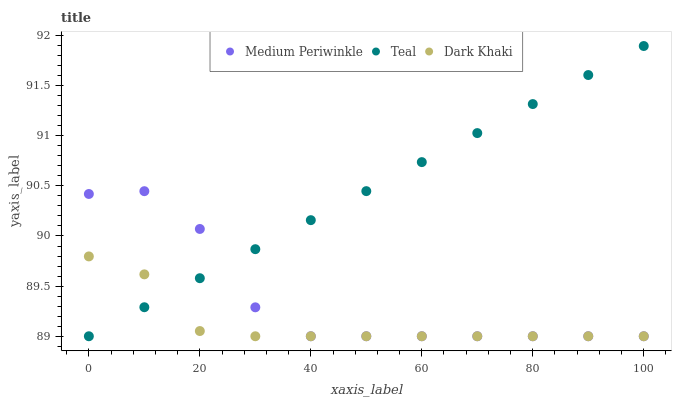Does Dark Khaki have the minimum area under the curve?
Answer yes or no. Yes. Does Teal have the maximum area under the curve?
Answer yes or no. Yes. Does Medium Periwinkle have the minimum area under the curve?
Answer yes or no. No. Does Medium Periwinkle have the maximum area under the curve?
Answer yes or no. No. Is Teal the smoothest?
Answer yes or no. Yes. Is Medium Periwinkle the roughest?
Answer yes or no. Yes. Is Medium Periwinkle the smoothest?
Answer yes or no. No. Is Teal the roughest?
Answer yes or no. No. Does Dark Khaki have the lowest value?
Answer yes or no. Yes. Does Teal have the highest value?
Answer yes or no. Yes. Does Medium Periwinkle have the highest value?
Answer yes or no. No. Does Dark Khaki intersect Medium Periwinkle?
Answer yes or no. Yes. Is Dark Khaki less than Medium Periwinkle?
Answer yes or no. No. Is Dark Khaki greater than Medium Periwinkle?
Answer yes or no. No. 